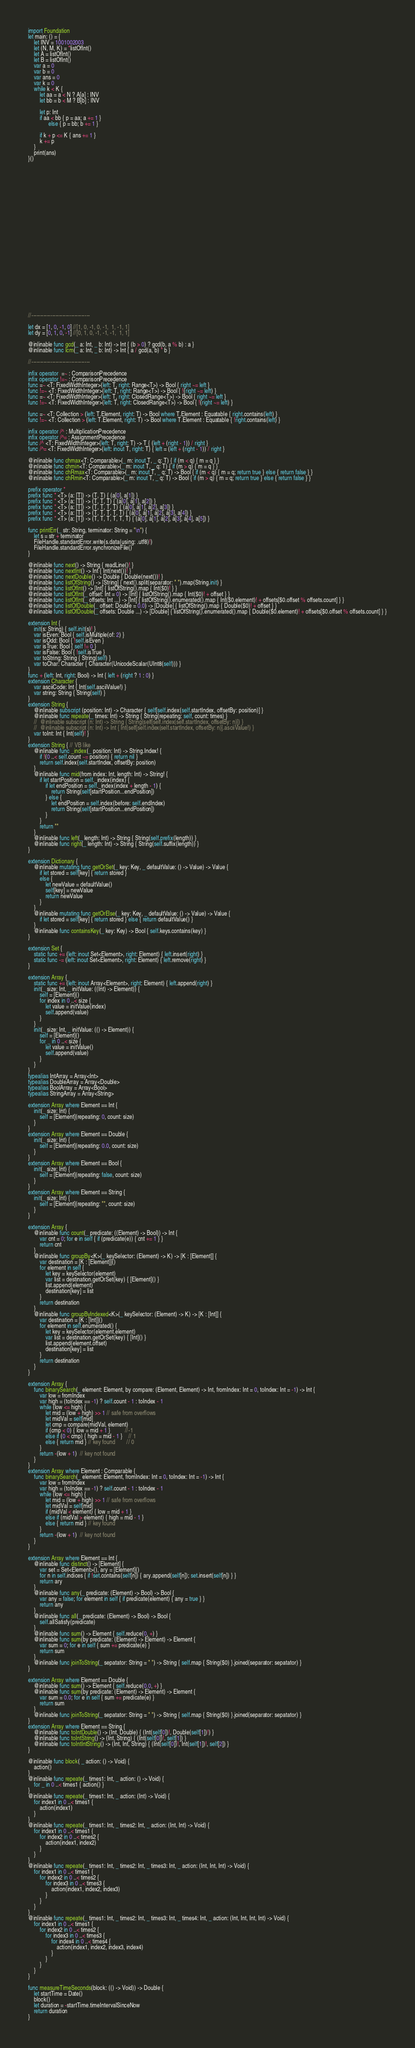<code> <loc_0><loc_0><loc_500><loc_500><_Swift_>





import Foundation
let main: () = {
    let INV = 1001002003
    let (N, M, K) = *listOfInt()
    let A = listOfInt()
    let B = listOfInt()
    var a = 0
    var b = 0
    var ans = 0
    var k = 0
    while k < K {
        let aa = a < N ? A[a] : INV
        let bb = b < M ? B[b] : INV
        
        let p: Int
        if aa < bb { p = aa; a += 1 }
              else { p = bb; b += 1 }
        
        if k + p <= K { ans += 1 }
        k += p
    }
    print(ans)
}()


























//----------------------------------

let dx = [1, 0, -1, 0] //[1, 0, -1, 0, -1,  1, -1, 1]
let dy = [0, 1, 0, -1] //[0, 1, 0, -1, -1, -1,  1, 1]

@inlinable func gcd(_ a: Int, _ b: Int) -> Int { (b > 0) ? gcd(b, a % b) : a }
@inlinable func lcm(_ a: Int, _ b: Int) -> Int { a / gcd(a, b) * b }

//----------------------------------

infix operator  =~ : ComparisonPrecedence
infix operator !=~ : ComparisonPrecedence
func =~ <T: FixedWidthInteger>(left: T, right: Range<T>) -> Bool { right ~= left }
func !=~ <T: FixedWidthInteger>(left: T, right: Range<T>) -> Bool { !(right ~= left) }
func =~ <T: FixedWidthInteger>(left: T, right: ClosedRange<T>) -> Bool { right ~= left }
func !=~ <T: FixedWidthInteger>(left: T, right: ClosedRange<T>) -> Bool { !(right ~= left) }

func =~ <T: Collection > (left: T.Element, right: T) -> Bool where T.Element : Equatable { right.contains(left) }
func !=~ <T: Collection > (left: T.Element, right: T) -> Bool where T.Element : Equatable { !right.contains(left) }

infix operator /^ : MultiplicationPrecedence
infix operator /^= : AssignmentPrecedence
func /^ <T: FixedWidthInteger>(left: T, right: T) -> T { (left + (right - 1)) / right }
func /^= <T: FixedWidthInteger>(left: inout T, right: T) { left = (left + (right - 1)) / right }

@inlinable func chmax<T: Comparable>(_ m: inout T, _ q: T) { if (m < q) { m = q } }
@inlinable func chmin<T: Comparable>(_ m: inout T, _ q: T) { if (m > q) { m = q } }
@inlinable func chRmax<T: Comparable>(_ m: inout T, _ q: T) -> Bool { if (m < q) { m = q; return true } else { return false } }
@inlinable func chRmin<T: Comparable>(_ m: inout T, _ q: T) -> Bool { if (m > q) { m = q; return true } else { return false } }

prefix operator *
prefix func * <T> (a: [T]) -> (T, T) { (a[0], a[1]) }
prefix func * <T> (a: [T]) -> (T, T, T) { (a[0], a[1], a[2]) }
prefix func * <T> (a: [T]) -> (T, T, T, T) { (a[0], a[1], a[2], a[3]) }
prefix func * <T> (a: [T]) -> (T, T, T, T, T) { (a[0], a[1], a[2], a[3], a[4]) }
prefix func * <T> (a: [T]) -> (T, T, T, T, T, T) { (a[0], a[1], a[2], a[3], a[4], a[5]) }

func printErr(_ str: String, terminator: String = "\n") {
    let s = str + terminator
    FileHandle.standardError.write(s.data(using: .utf8)!)
    FileHandle.standardError.synchronizeFile()
}

@inlinable func next() -> String { readLine()! }
@inlinable func nextInt() -> Int { Int(next())! }
@inlinable func nextDouble() -> Double { Double(next())! }
@inlinable func listOfString() -> [String] { next().split(separator: " ").map(String.init) }
@inlinable func listOfInt() -> [Int] { listOfString().map { Int($0)! } }
@inlinable func listOfInt(_ offset: Int = 0) -> [Int] { listOfString().map { Int($0)! + offset } }
@inlinable func listOfInt(_ offsets: Int ...) -> [Int] { listOfString().enumerated().map { Int($0.element)! + offsets[$0.offset % offsets.count] } }
@inlinable func listOfDouble(_ offset: Double = 0.0) -> [Double] { listOfString().map { Double($0)! + offset } }
@inlinable func listOfDouble(_ offsets: Double ...) -> [Double] { listOfString().enumerated().map { Double($0.element)! + offsets[$0.offset % offsets.count] } }

extension Int {
    init(s: String) { self.init(s)! }
    var isEven: Bool { self.isMultiple(of: 2) }
    var isOdd: Bool { !self.isEven }
    var isTrue: Bool { self != 0 }
    var isFalse: Bool { !self.isTrue }
    var toString: String { String(self) }
    var toChar: Character { Character(UnicodeScalar(UInt8(self))) }
}
func + (left: Int, right: Bool) -> Int { left + (right ? 1 : 0) }
extension Character {
    var asciiCode: Int { Int(self.asciiValue!) }
    var string: String { String(self) }
}
extension String {
    @inlinable subscript (position: Int) -> Character { self[self.index(self.startIndex, offsetBy: position)] }
    @inlinable func repeate(_ times: Int) -> String { String(repeating: self, count: times) }
    //  @inlinable subscript (n: Int) -> String { String(self[self.index(self.startIndex, offsetBy: n)]) }
    //  @inlinable subscript (n: Int) -> Int { Int(self[self.index(self.startIndex, offsetBy: n)].asciiValue!) }
    var toInt: Int { Int(self)! }
}
extension String { // VB like
    @inlinable func _index(_ position: Int) -> String.Index! {
        if !(0 ..< self.count ~= position) { return nil }
        return self.index(self.startIndex, offsetBy: position)
    }
    @inlinable func mid(from index: Int, length: Int) -> String! {
        if let startPosition = self._index(index) {
            if let endPosition = self._index(index + length - 1) {
                return String(self[startPosition...endPosition])
            } else {
                let endPosition = self.index(before: self.endIndex)
                return String(self[startPosition...endPosition])
            }
        }
        return ""
    }
    @inlinable func left(_ length: Int) -> String { String(self.prefix(length)) }
    @inlinable func right(_ length: Int) -> String { String(self.suffix(length)) }
}

extension Dictionary {
    @inlinable mutating func getOrSet(_ key: Key, _ defaultValue: () -> Value) -> Value {
        if let stored = self[key] { return stored }
        else {
            let newValue = defaultValue()
            self[key] = newValue
            return newValue
        }
    }
    @inlinable mutating func getOrElse(_ key: Key, _ defaultValue: () -> Value) -> Value {
        if let stored = self[key] { return stored } else { return defaultValue() }
    }
    @inlinable func containsKey(_ key: Key) -> Bool { self.keys.contains(key) }
}

extension Set {
    static func += (left: inout Set<Element>, right: Element) { left.insert(right) }
    static func -= (left: inout Set<Element>, right: Element) { left.remove(right) }
}

extension Array {
    static func += (left: inout Array<Element>, right: Element) { left.append(right) }
    init(_ size: Int, _ initValue: ((Int) -> Element)) {
        self = [Element]()
        for index in 0 ..< size {
            let value = initValue(index)
            self.append(value)
        }
    }
    init(_ size: Int, _ initValue: (() -> Element)) {
        self = [Element]()
        for _ in 0 ..< size {
            let value = initValue()
            self.append(value)
        }
    }
}
typealias IntArray = Array<Int>
typealias DoubleArray = Array<Double>
typealias BoolArray = Array<Bool>
typealias StringArray = Array<String>

extension Array where Element == Int {
    init(_ size: Int) {
        self = [Element](repeating: 0, count: size)
    }
}
extension Array where Element == Double {
    init(_ size: Int) {
        self = [Element](repeating: 0.0, count: size)
    }
}
extension Array where Element == Bool {
    init(_ size: Int) {
        self = [Element](repeating: false, count: size)
    }
}
extension Array where Element == String {
    init(_ size: Int) {
        self = [Element](repeating: "", count: size)
    }
}

extension Array {
    @inlinable func count(_ predicate: ((Element) -> Bool)) -> Int {
        var cnt = 0; for e in self { if (predicate(e)) { cnt += 1 } }
        return cnt
    }
    @inlinable func groupBy<K>(_ keySelector: (Element) -> K) -> [K : [Element]] {
        var destination = [K : [Element]]()
        for element in self {
            let key = keySelector(element)
            var list = destination.getOrSet(key) { [Element]() }
            list.append(element)
            destination[key] = list
        }
        return destination
    }
    @inlinable func groupByIndexed<K>(_ keySelector: (Element) -> K) -> [K : [Int]] {
        var destination = [K : [Int]]()
        for element in self.enumerated() {
            let key = keySelector(element.element)
            var list = destination.getOrSet(key) { [Int]() }
            list.append(element.offset)
            destination[key] = list
        }
        return destination
    }
}

extension Array {
    func binarySearch(_ element: Element, by compare: (Element, Element) -> Int, fromIndex: Int = 0, toIndex: Int = -1) -> Int {
        var low = fromIndex
        var high = (toIndex == -1) ? self.count - 1 : toIndex - 1
        while (low <= high) {
            let mid = (low + high) >> 1 // safe from overflows
            let midVal = self[mid]
            let cmp = compare(midVal, element)
            if (cmp < 0) { low = mid + 1 }          //-1
            else if (0 < cmp) { high = mid - 1 }    // 1
            else { return mid } // key found        // 0
        }
        return -(low + 1)  // key not found
    }
}
extension Array where Element : Comparable {
    func binarySearch(_ element: Element, fromIndex: Int = 0, toIndex: Int = -1) -> Int {
        var low = fromIndex
        var high = (toIndex == -1) ? self.count - 1 : toIndex - 1
        while (low <= high) {
            let mid = (low + high) >> 1 // safe from overflows
            let midVal = self[mid]
            if (midVal < element) { low = mid + 1 }
            else if (midVal > element) { high = mid - 1 }
            else { return mid } // key found
        }
        return -(low + 1)  // key not found
    }
}

extension Array where Element == Int {
    @inlinable func distinct() -> [Element] {
        var set = Set<Element>(), ary = [Element]()
        for n in self.indices { if !set.contains(self[n]) { ary.append(self[n]); set.insert(self[n]) } }
        return ary
    }
    @inlinable func any(_ predicate: (Element) -> Bool) -> Bool {
        var any = false; for element in self { if predicate(element) { any = true } }
        return any
    }
    @inlinable func all(_ predicate: (Element) -> Bool) -> Bool {
        self.allSatisfy(predicate)
    }
    @inlinable func sum() -> Element { self.reduce(0, +) }
    @inlinable func sum(by predicate: (Element) -> Element) -> Element {
        var sum = 0; for e in self { sum += predicate(e) }
        return sum
    }
    @inlinable func joinToString(_ sepatator: String = " ") -> String { self.map { String($0) }.joined(separator: sepatator) }
}

extension Array where Element == Double {
    @inlinable func sum() -> Element { self.reduce(0.0, +) }
    @inlinable func sum(by predicate: (Element) -> Element) -> Element {
        var sum = 0.0; for e in self { sum += predicate(e) }
        return sum
    }
    @inlinable func joinToString(_ sepatator: String = " ") -> String { self.map { String($0) }.joined(separator: sepatator) }
}
extension Array where Element == String {
    @inlinable func toIntDouble() -> (Int, Double) { (Int(self[0])!, Double(self[1])!) }
    @inlinable func toIntString() -> (Int, String) { (Int(self[0])!, self[1]) }
    @inlinable func toIntIntString() -> (Int, Int, String) { (Int(self[0])!, Int(self[1])!, self[2]) }
}

@inlinable func block( _ action: () -> Void) {
    action()
}
@inlinable func repeate(_ times1: Int, _ action: () -> Void) {
    for _ in 0 ..< times1 { action() }
}
@inlinable func repeate(_ times1: Int, _ action: (Int) -> Void) {
    for index1 in 0 ..< times1 {
        action(index1)
    }
}
@inlinable func repeate(_ times1: Int, _ times2: Int, _ action: (Int, Int) -> Void) {
    for index1 in 0 ..< times1 {
        for index2 in 0 ..< times2 {
            action(index1, index2)
        }
    }
}
@inlinable func repeate(_ times1: Int, _ times2: Int, _ times3: Int, _ action: (Int, Int, Int) -> Void) {
    for index1 in 0 ..< times1 {
        for index2 in 0 ..< times2 {
            for index3 in 0 ..< times3 {
                action(index1, index2, index3)
            }
        }
    }
}
@inlinable func repeate(_ times1: Int, _ times2: Int, _ times3: Int, _ times4: Int, _ action: (Int, Int, Int, Int) -> Void) {
    for index1 in 0 ..< times1 {
        for index2 in 0 ..< times2 {
            for index3 in 0 ..< times3 {
                for index4 in 0 ..< times4 {
                    action(index1, index2, index3, index4)
                }
            }
        }
    }
}

func measureTimeSeconds(block: (() -> Void)) -> Double {
    let startTime = Date()
    block()
    let duration = -startTime.timeIntervalSinceNow
    return duration
}
</code> 